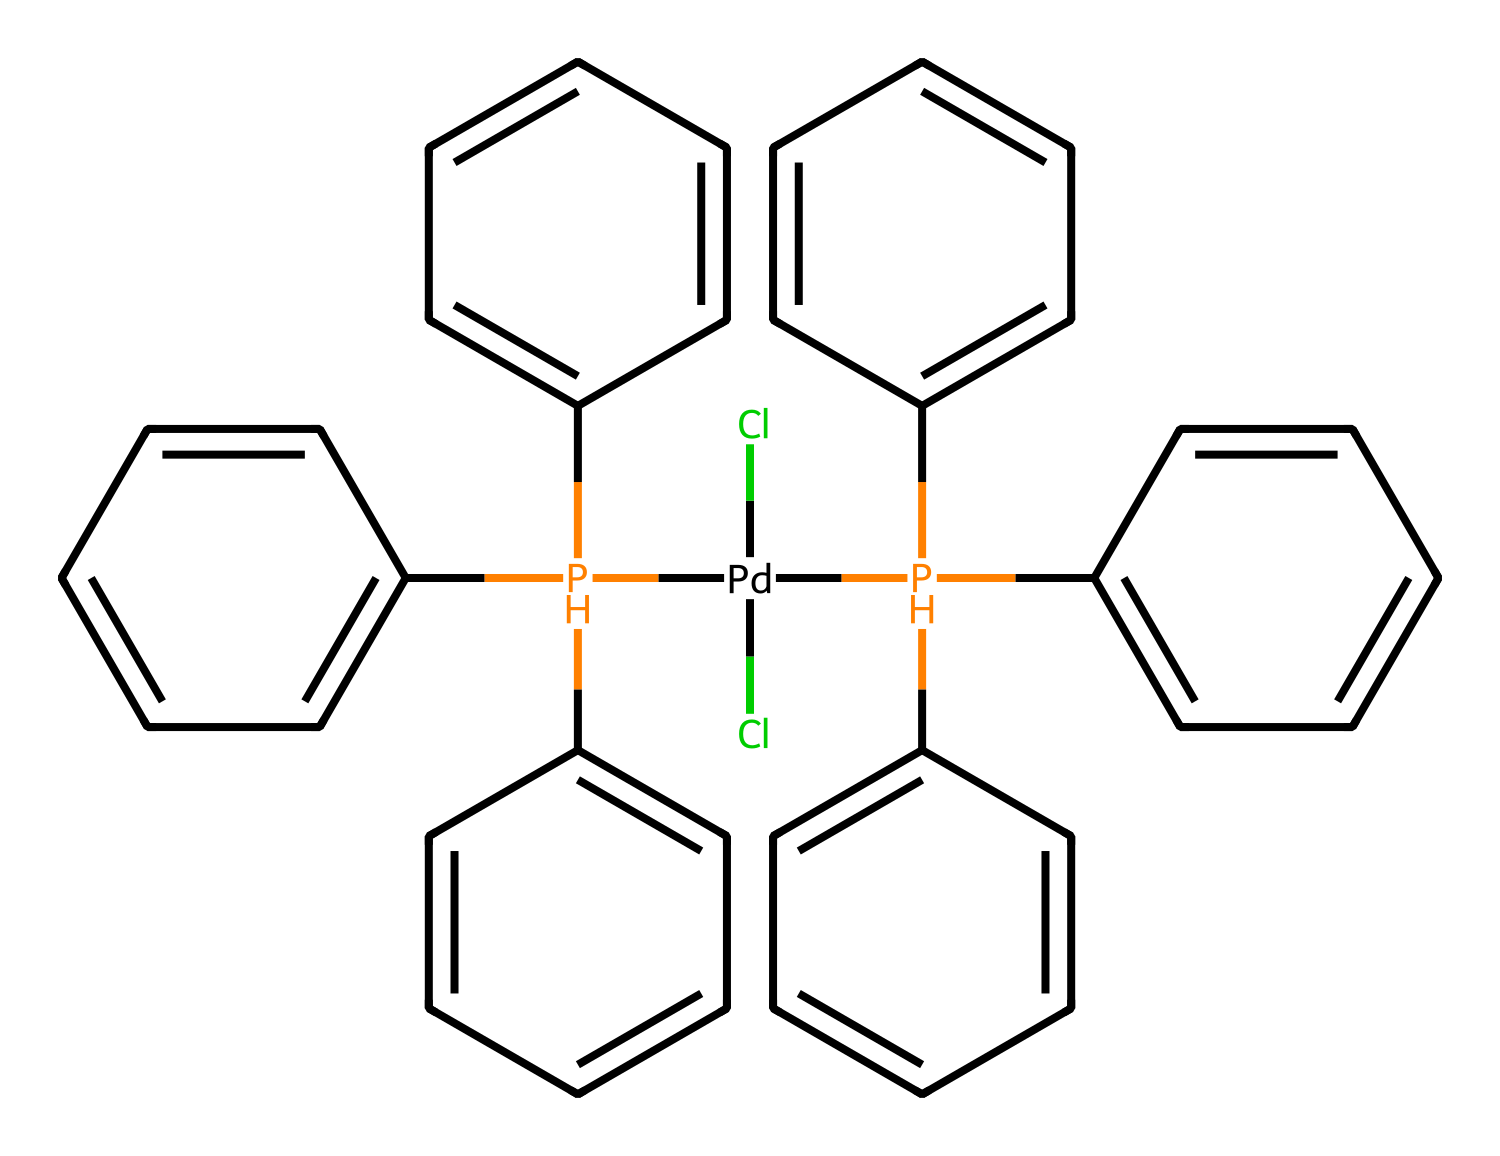What is the central metal atom in this organometallic compound? The central metal atom can be identified by locating the palladium atom (Pd) in the SMILES notation, which indicates its central position surrounded by ligands.
Answer: palladium How many chlorine atoms are present in this compound? The number of chlorine atoms can be determined by counting the 'Cl' symbols in the SMILES representation; there are two 'Cl' symbols indicating two chlorine atoms.
Answer: two What is the ligand type present in the compound? The ligands can be identified from the SMILES notation as 'P(c'...')', indicating that triphenylphosphine ligands are attached to the palladium center.
Answer: phosphine What is the total number of phenyl rings in this compound? By counting the 'c' characters within the parentheses in the SMILES, each set corresponds to a phenyl ring; there are six phenyl rings in total in the structure.
Answer: six How many coordination sites does the palladium in this compound have? The coordination sites can be derived from the chemical structure, recognizing that the palladium is bonded to two chlorine atoms and two phosphine ligands, implying that it has a total of four coordination sites.
Answer: four What type of reaction mechanism does this compound facilitate in electronic component manufacturing? This compound is typically involved in coupling reactions, such as Suzuki or Heck reactions, which are common in creating complex organic molecules necessary for electronics.
Answer: coupling reactions 